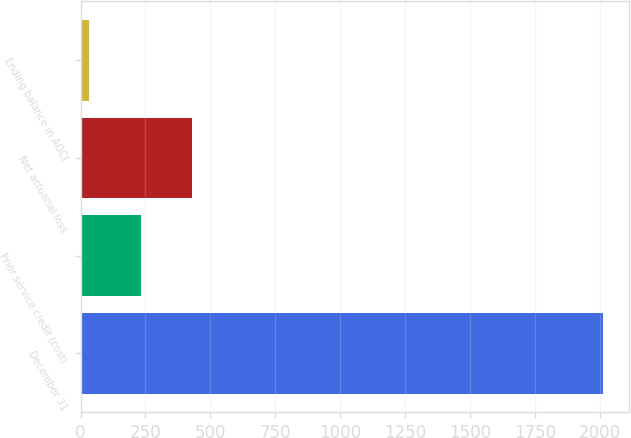Convert chart. <chart><loc_0><loc_0><loc_500><loc_500><bar_chart><fcel>December 31<fcel>Prior service credit (cost)<fcel>Net actuarial loss<fcel>Ending balance in AOCI<nl><fcel>2011<fcel>231.7<fcel>429.4<fcel>34<nl></chart> 